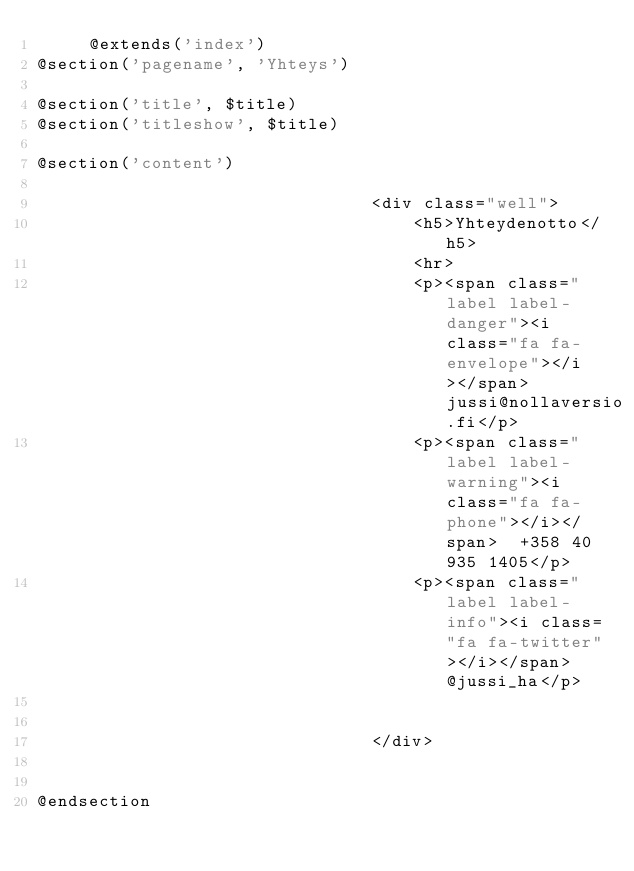<code> <loc_0><loc_0><loc_500><loc_500><_PHP_>     @extends('index')
@section('pagename', 'Yhteys')

@section('title', $title)
@section('titleshow', $title)

@section('content')
    
								<div class="well">
									<h5>Yhteydenotto</h5>
									<hr>
									<p><span class="label label-danger"><i class="fa fa-envelope"></i></span>  jussi@nollaversio.fi</p>
									<p><span class="label label-warning"><i class="fa fa-phone"></i></span>  +358 40 935 1405</p>
									<p><span class="label label-info"><i class="fa fa-twitter"></i></span>  @jussi_ha</p>


								</div>             

																																	
@endsection     </code> 